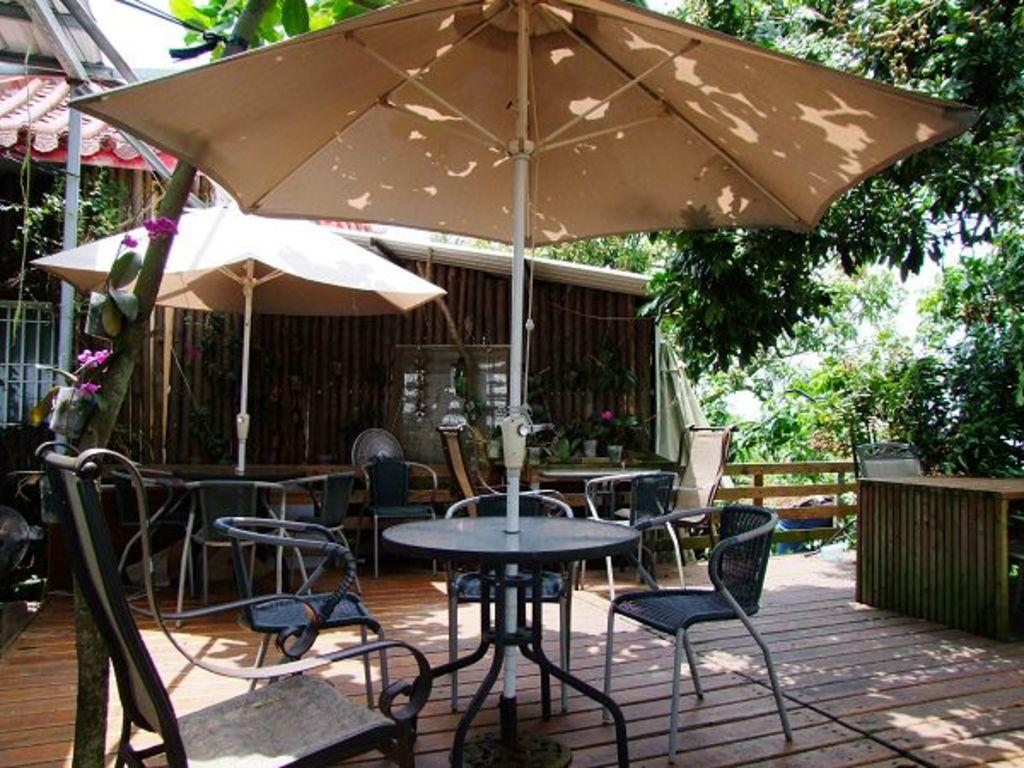What type of furniture is present in the image? There are chairs and tables in the image. What objects are present to provide shade or shelter? There are umbrellas in the image. What can be seen in the background of the image? There is a house, metal rods, and trees in the background of the image. What type of canvas is being used for learning in the middle of the image? There is no canvas or learning activity present in the image. 